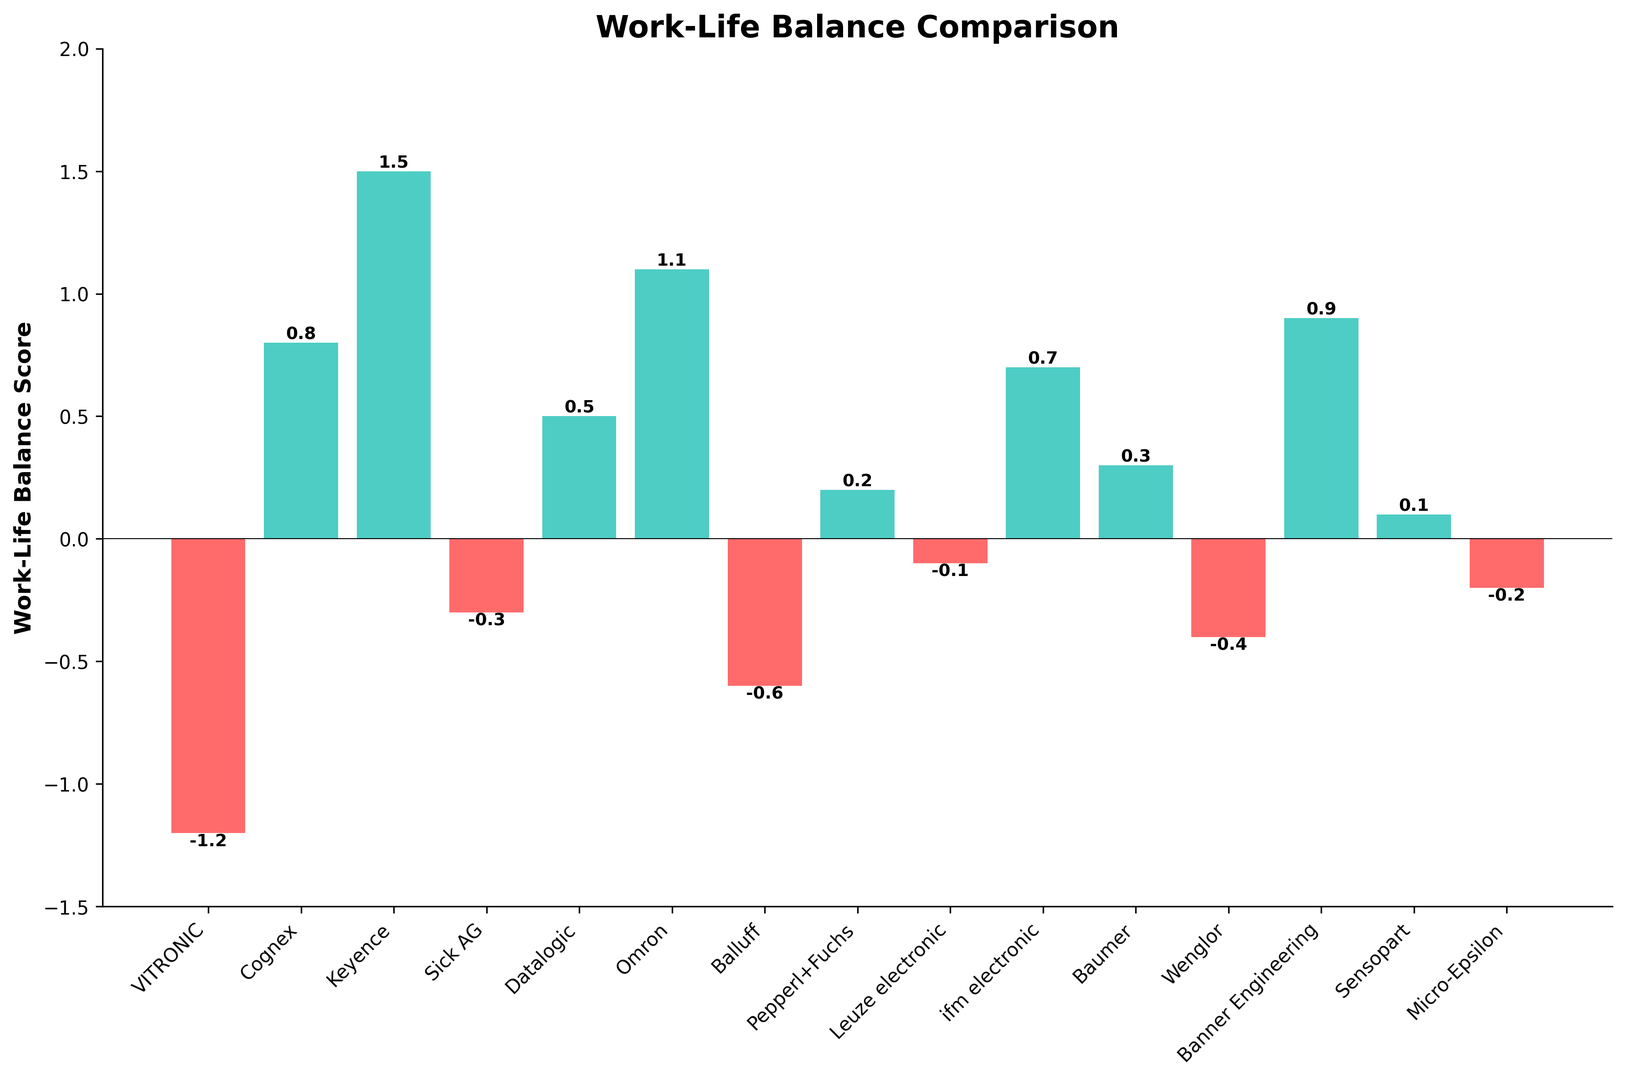What is the work-life balance score of VITRONIC? Refer to the bar labeled "VITRONIC" and observe the height of the bar. The score is -1.2.
Answer: -1.2 Which company has the highest work-life balance score? Look for the tallest bar above the zero line. The longest bar belongs to Keyence with a score of 1.5.
Answer: Keyence How many companies have a work-life balance score lower than 0? Count all the bars that extend below the zero line. Bars for VITRONIC, Sick AG, Balluff, Leuze electronic, Wenglor, and Micro-Epsilon fall into this category, making a total of 6 companies.
Answer: 6 Compare the work-life balance score of Cognex and Omron. Which company has a higher score? Compare the lengths of the bars for Cognex and Omron. Cognex has a score of 0.8, while Omron has a score of 1.1. Omron has a higher score.
Answer: Omron What is the average work-life balance score for VITRONIC, Cognex, and Keyence? Find the scores for VITRONIC (-1.2), Cognex (0.8), and Keyence (1.5). Sum these scores: -1.2 + 0.8 + 1.5 = 1.1. Divide by the number of companies (3): 1.1 / 3 = 0.367
Answer: 0.367 Which companies have a work-life balance score greater than 1.0? Identify the bars extending above the 1.0 mark. Keyence (1.5) and Omron (1.1) are the companies with scores greater than 1.0.
Answer: Keyence, Omron What is the median work-life balance score of the listed companies? List all the scores in ascending order: -1.2, -0.6, -0.4, -0.3, -0.2, -0.1, 0.1, 0.2, 0.3, 0.5, 0.7, 0.8, 0.9, 1.1, 1.5. The median score is the middle value of this ordered list (i.e., the 8th value), which is 0.2.
Answer: 0.2 Is the work-life balance score of VITRONIC lower than the score of Baumer? Compare the height of the bars for VITRONIC and Baumer. VITRONIC's score is -1.2, while Baumer's score is 0.3. Yes, VITRONIC's score is lower.
Answer: Yes What is the total work-life balance score for Sick AG and Micro-Epsilon? Add the scores for Sick AG (-0.3) and Micro-Epsilon (-0.2). -0.3 + -0.2 = -0.5
Answer: -0.5 